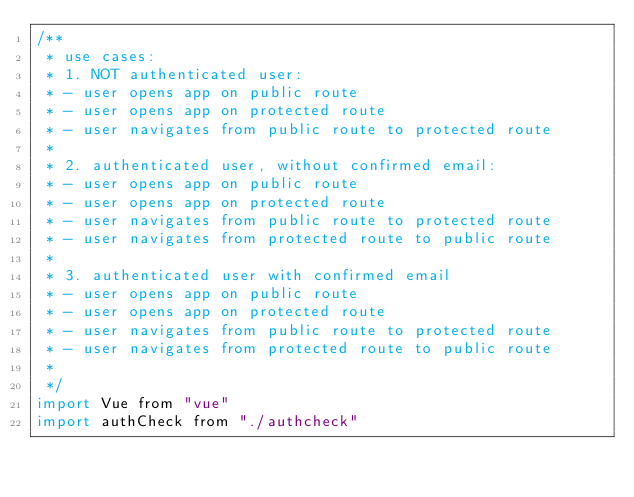<code> <loc_0><loc_0><loc_500><loc_500><_JavaScript_>/**
 * use cases:
 * 1. NOT authenticated user:
 * - user opens app on public route
 * - user opens app on protected route
 * - user navigates from public route to protected route
 *
 * 2. authenticated user, without confirmed email:
 * - user opens app on public route
 * - user opens app on protected route
 * - user navigates from public route to protected route
 * - user navigates from protected route to public route
 *
 * 3. authenticated user with confirmed email
 * - user opens app on public route
 * - user opens app on protected route
 * - user navigates from public route to protected route
 * - user navigates from protected route to public route
 *
 */
import Vue from "vue"
import authCheck from "./authcheck"
</code> 